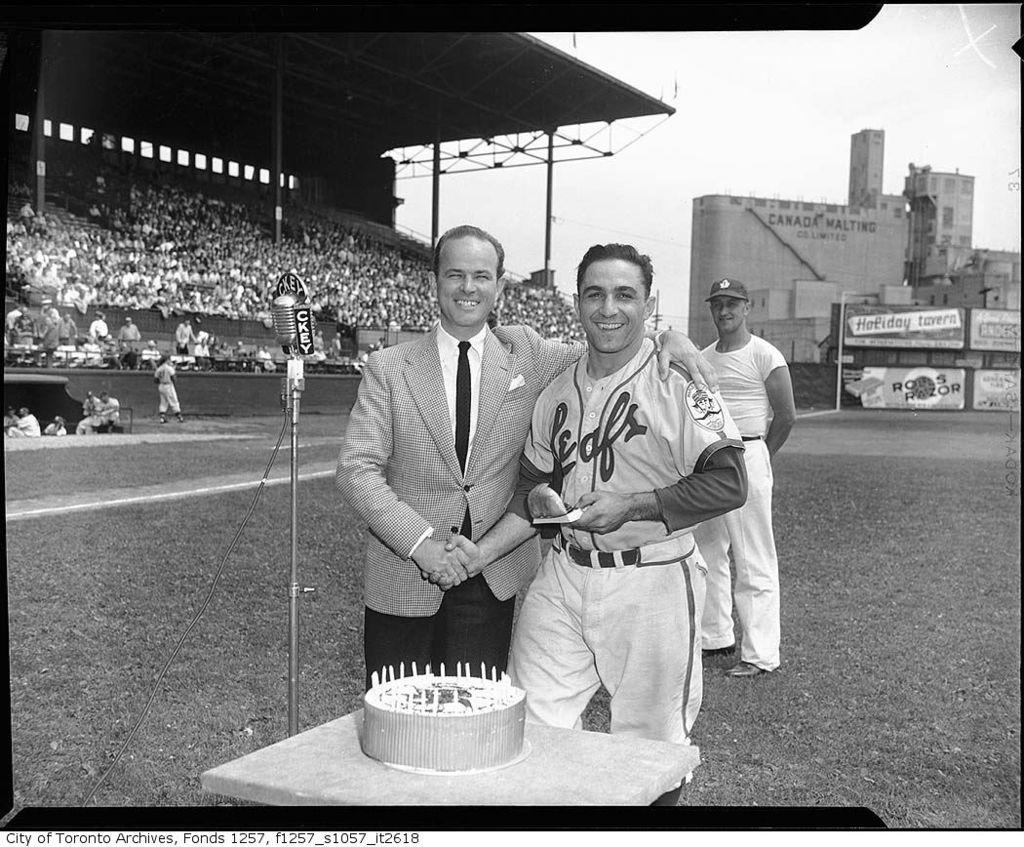<image>
Create a compact narrative representing the image presented. Man standing next to another man with the word leaf on his chest. 